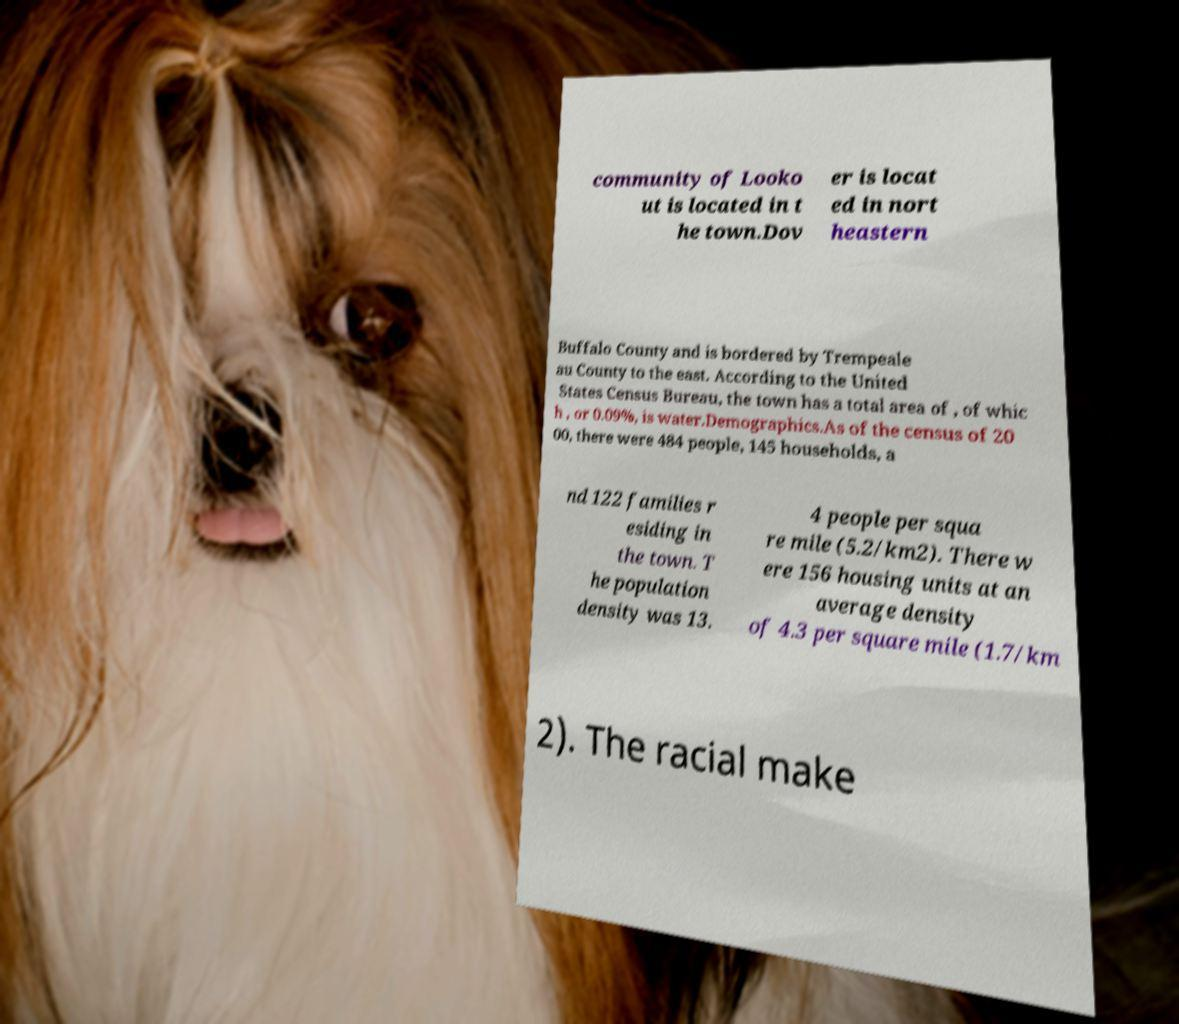There's text embedded in this image that I need extracted. Can you transcribe it verbatim? community of Looko ut is located in t he town.Dov er is locat ed in nort heastern Buffalo County and is bordered by Trempeale au County to the east. According to the United States Census Bureau, the town has a total area of , of whic h , or 0.09%, is water.Demographics.As of the census of 20 00, there were 484 people, 145 households, a nd 122 families r esiding in the town. T he population density was 13. 4 people per squa re mile (5.2/km2). There w ere 156 housing units at an average density of 4.3 per square mile (1.7/km 2). The racial make 